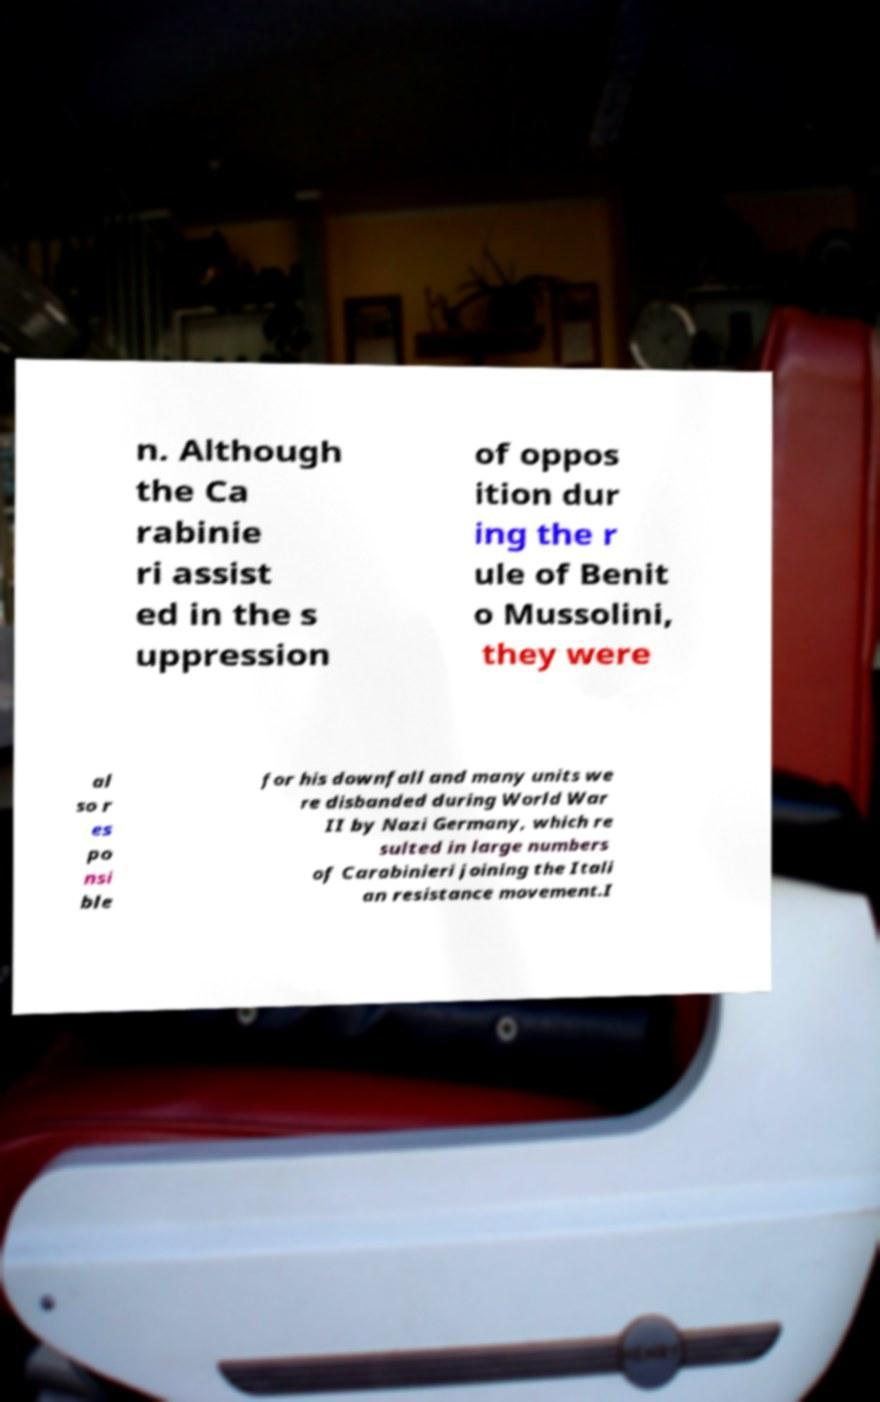For documentation purposes, I need the text within this image transcribed. Could you provide that? n. Although the Ca rabinie ri assist ed in the s uppression of oppos ition dur ing the r ule of Benit o Mussolini, they were al so r es po nsi ble for his downfall and many units we re disbanded during World War II by Nazi Germany, which re sulted in large numbers of Carabinieri joining the Itali an resistance movement.I 